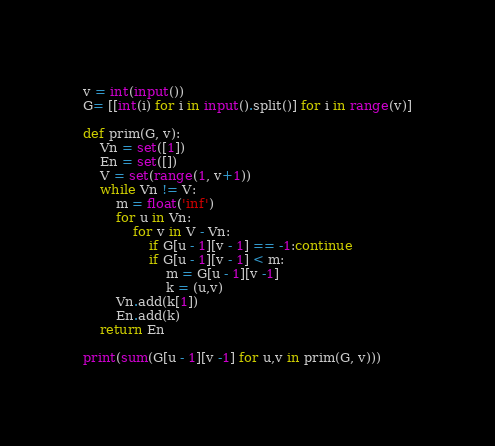<code> <loc_0><loc_0><loc_500><loc_500><_Python_>v = int(input())
G= [[int(i) for i in input().split()] for i in range(v)]
        
def prim(G, v):
    Vn = set([1])
    En = set([])
    V = set(range(1, v+1))
    while Vn != V:
        m = float('inf')
        for u in Vn:
            for v in V - Vn:
                if G[u - 1][v - 1] == -1:continue
                if G[u - 1][v - 1] < m:
                    m = G[u - 1][v -1]
                    k = (u,v)
        Vn.add(k[1])
        En.add(k)
    return En

print(sum(G[u - 1][v -1] for u,v in prim(G, v)))</code> 